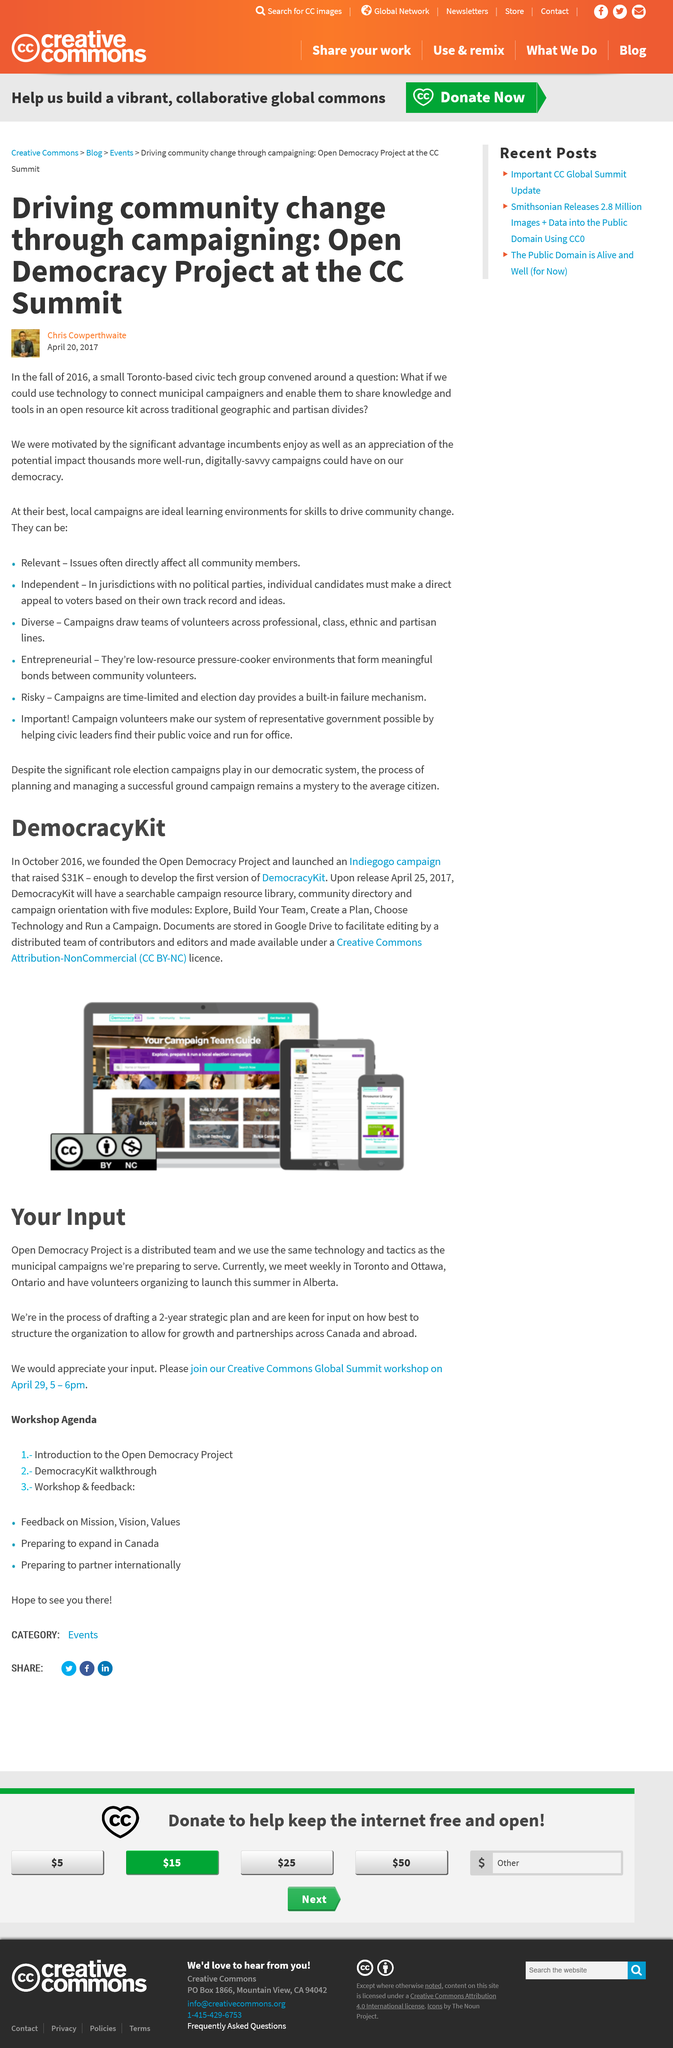Draw attention to some important aspects in this diagram. In this DemocracyKit article, three device screens are displayed in an image. The image features a desktop screen, a tablet screen, and a smart phone screen. The Open Democracy Project's strategic plan is two years in duration. It is recommended that campaigners share knowledge in an open resource kit. DemocracyKit documents are stored in Google Drive. Open Democracy Project operates across Canada and internationally, allowing for growth and partnerships in both regions. 